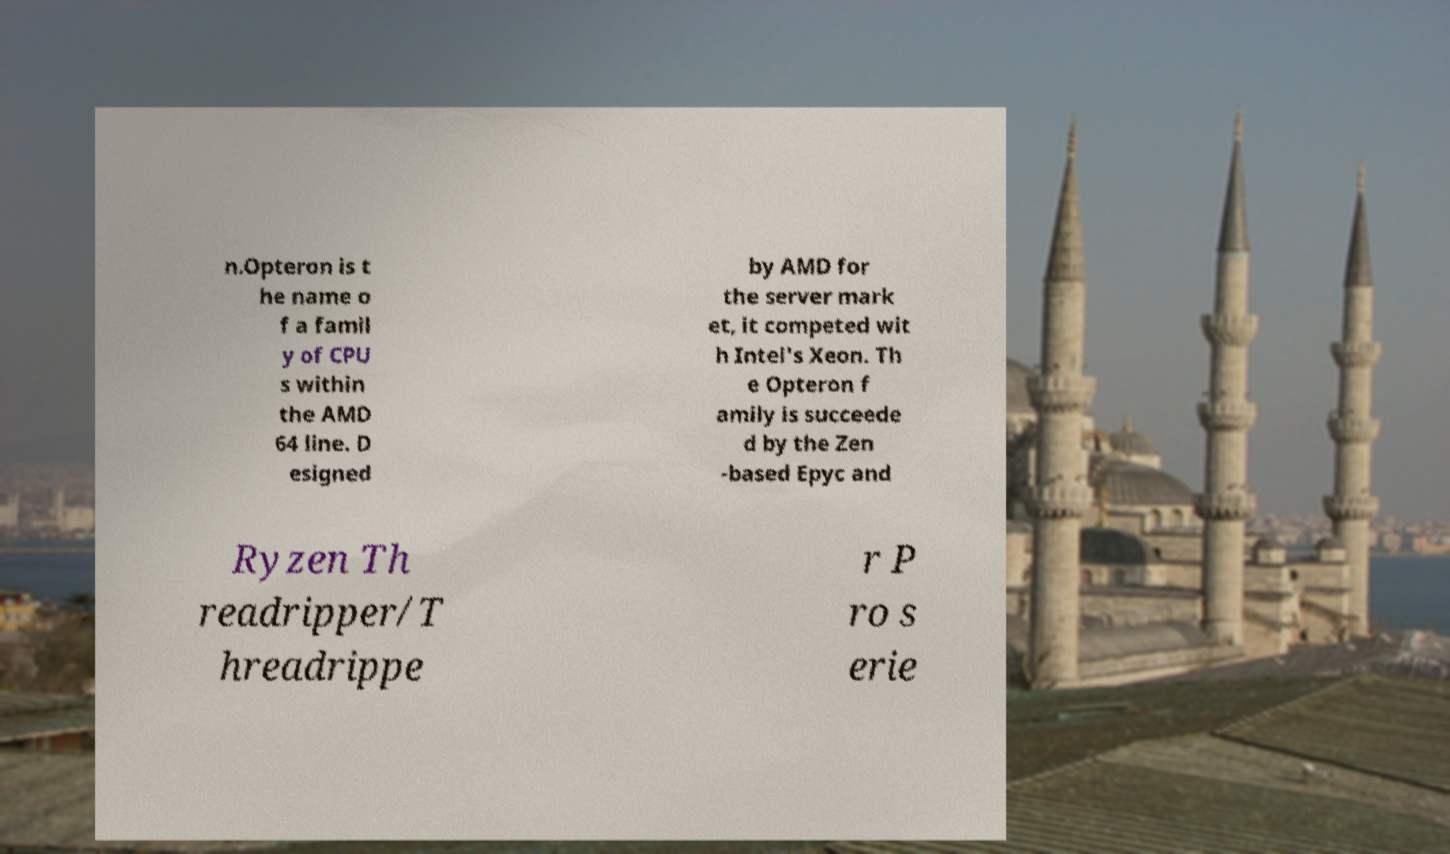There's text embedded in this image that I need extracted. Can you transcribe it verbatim? n.Opteron is t he name o f a famil y of CPU s within the AMD 64 line. D esigned by AMD for the server mark et, it competed wit h Intel's Xeon. Th e Opteron f amily is succeede d by the Zen -based Epyc and Ryzen Th readripper/T hreadrippe r P ro s erie 